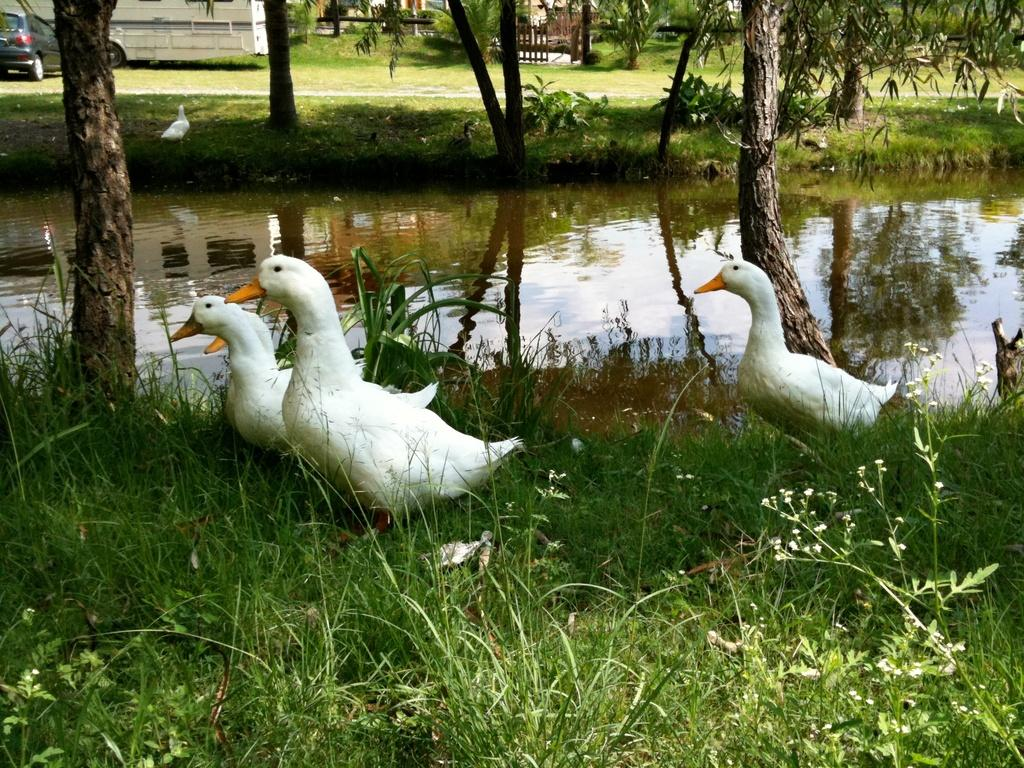What color are the ducks in the image? The ducks in the image are white. Where are the ducks located in the image? The ducks are standing on the grass. What can be seen in the background of the image? There are trees, water, and vehicles visible in the background of the image. What type of terrain is present in the image? There is grass on the ground in the image. What type of berry is growing on the edge of the image? There are no berries or edges present in the image; it features white ducks standing on grass with a background of trees, water, and vehicles. 